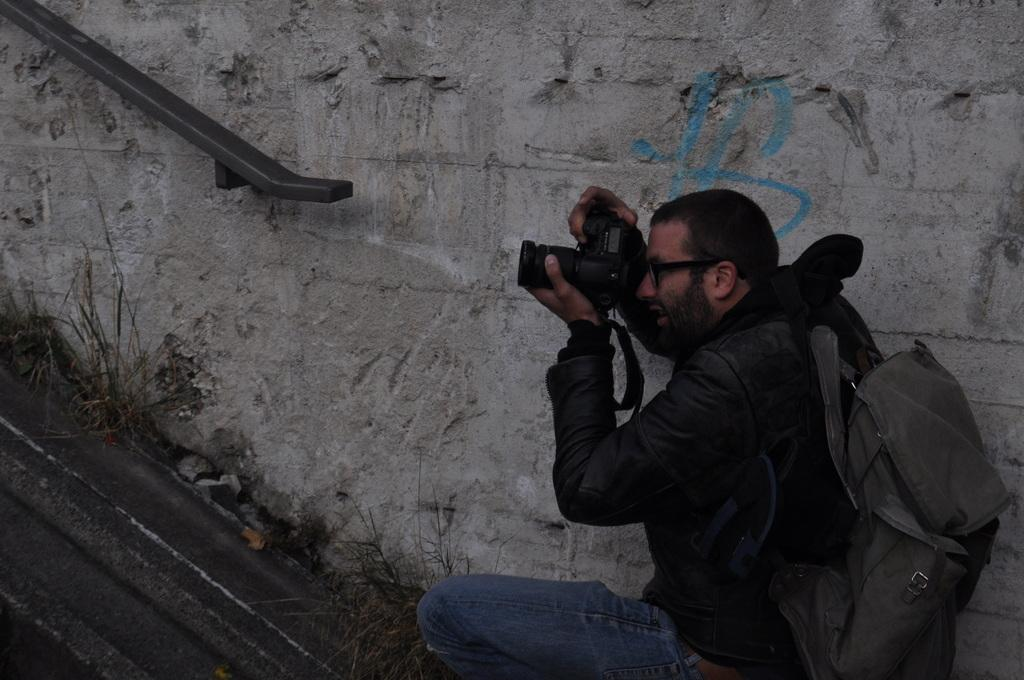Who is the main subject in the image? There is a man in the image. What is the man doing in the image? The man is catching a camera in his hand. What is the man wearing in the image? The man is wearing a bag and a black color jacket. What type of terrain is visible in the image? A: There is grass visible in the image. What type of holiday is the man celebrating in the image? There is no indication of a holiday in the image. Can you see any iron objects in the image? There are no iron objects visible in the image. 